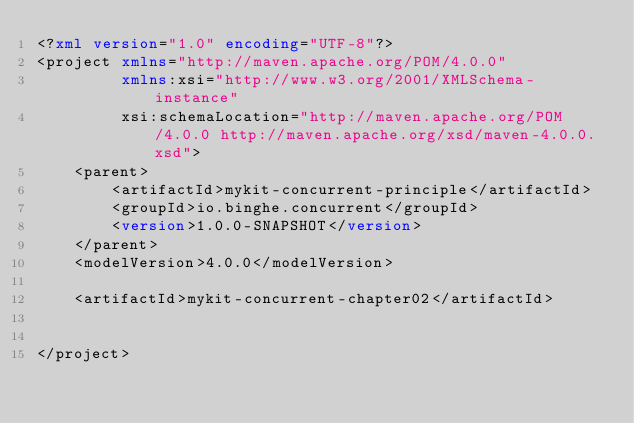Convert code to text. <code><loc_0><loc_0><loc_500><loc_500><_XML_><?xml version="1.0" encoding="UTF-8"?>
<project xmlns="http://maven.apache.org/POM/4.0.0"
         xmlns:xsi="http://www.w3.org/2001/XMLSchema-instance"
         xsi:schemaLocation="http://maven.apache.org/POM/4.0.0 http://maven.apache.org/xsd/maven-4.0.0.xsd">
    <parent>
        <artifactId>mykit-concurrent-principle</artifactId>
        <groupId>io.binghe.concurrent</groupId>
        <version>1.0.0-SNAPSHOT</version>
    </parent>
    <modelVersion>4.0.0</modelVersion>

    <artifactId>mykit-concurrent-chapter02</artifactId>


</project></code> 